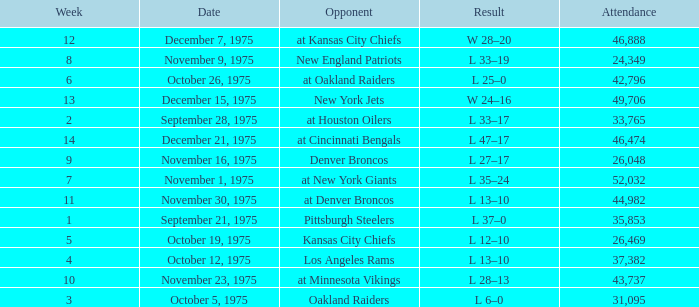What is the average Week when the result was w 28–20, and there were more than 46,888 in attendance? None. 